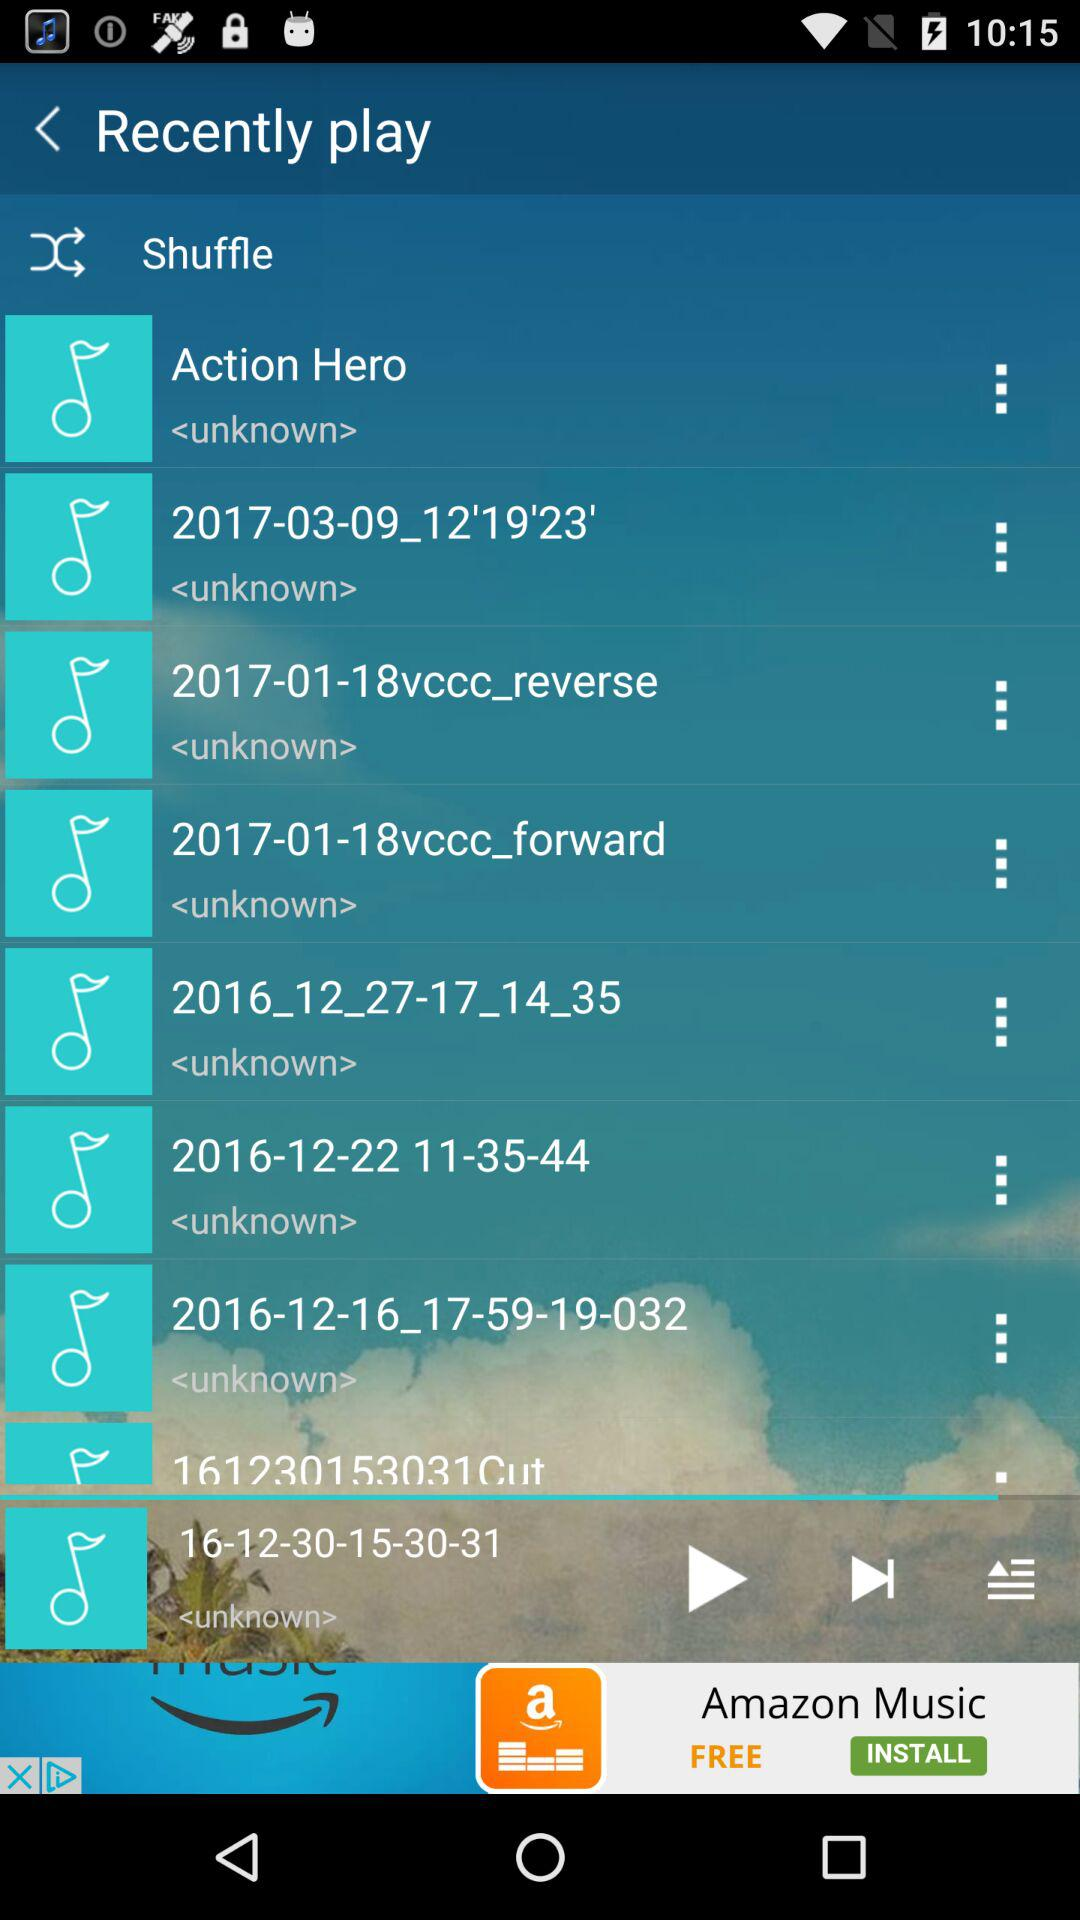What's the current playing song? The current playing song is 16-12-30-15-30-31. 